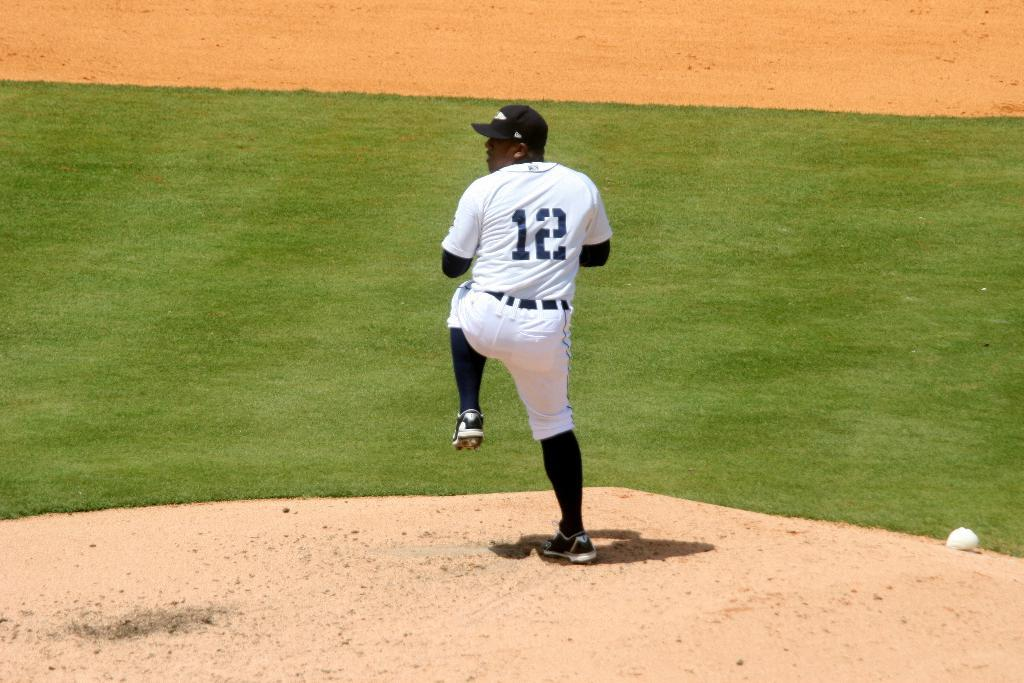<image>
Relay a brief, clear account of the picture shown. A pitcher in a number 12 uniform gets ready to throw the ball. 